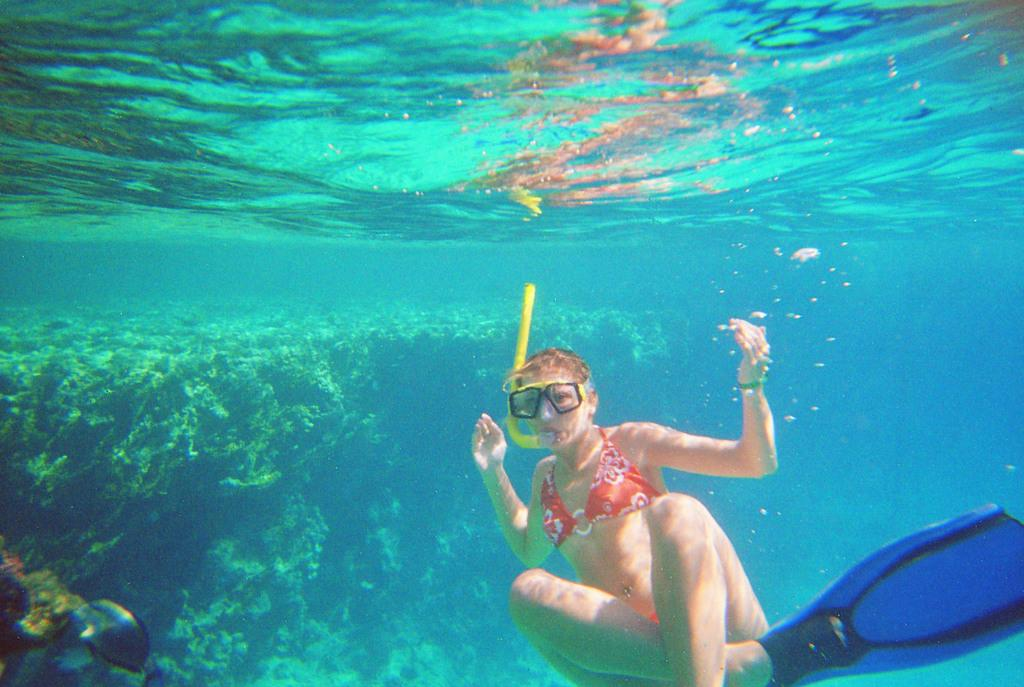Who is present in the image? There is a woman in the image. What is the woman wearing? The woman is wearing a swim dress. Can you describe the setting of the image? The image is taken underwater. What type of salt can be seen in the image? There is no salt present in the image. Is the woman playing volleyball in the image? There is no volleyball or indication of playing volleyball in the image. 